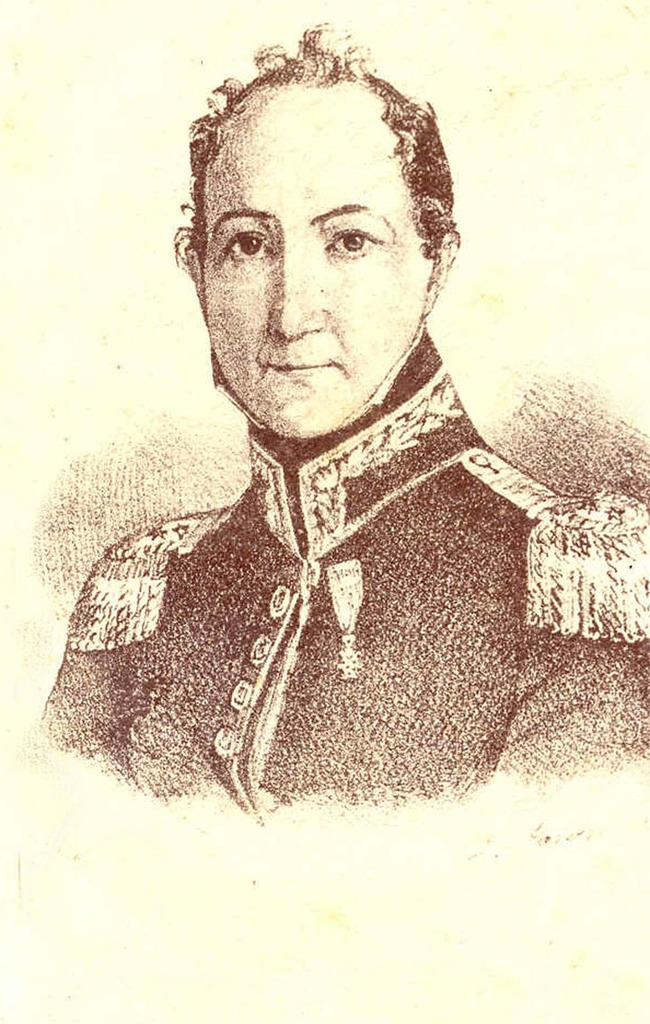What is the color of the surface in the image? The surface in the image is cream-colored. What can be seen on the surface? There is a drawing of a person on the surface. What is the person in the drawing wearing? The person in the drawing is wearing a uniform. What color is the uniform in the drawing? The uniform is brown in color. How many plates are stacked on top of each other in the image? There are no plates visible in the image. Can you describe the donkey in the image? There is no donkey present in the image. 